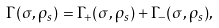Convert formula to latex. <formula><loc_0><loc_0><loc_500><loc_500>\Gamma ( \sigma , \rho _ { s } ) = \Gamma _ { + } ( \sigma , \rho _ { s } ) + \Gamma _ { - } ( \sigma , \rho _ { s } ) ,</formula> 